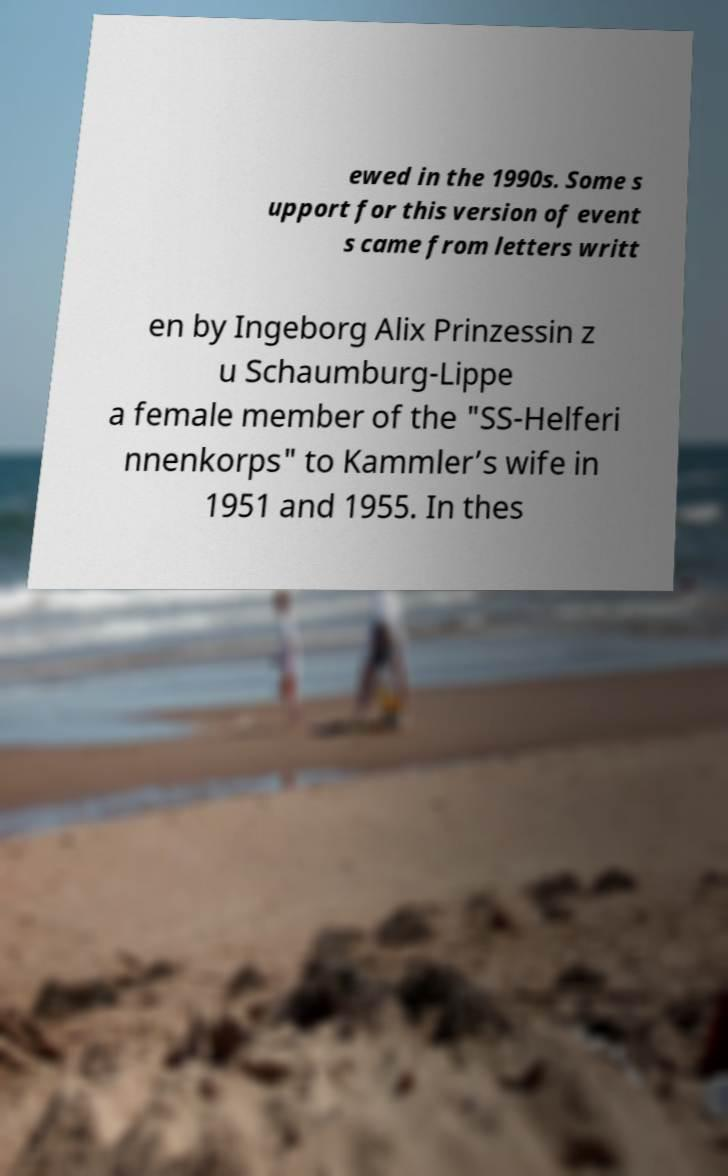Could you extract and type out the text from this image? ewed in the 1990s. Some s upport for this version of event s came from letters writt en by Ingeborg Alix Prinzessin z u Schaumburg-Lippe a female member of the "SS-Helferi nnenkorps" to Kammler’s wife in 1951 and 1955. In thes 